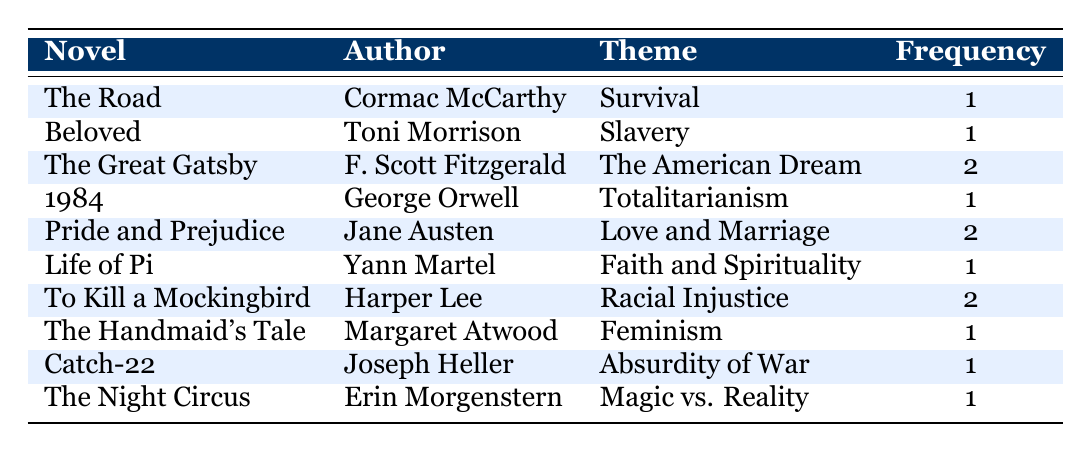What is the theme of "To Kill a Mockingbird"? "To Kill a Mockingbird" has the theme of "Racial Injustice," as directly stated in the table.
Answer: Racial Injustice How many novels have the theme of "Survival"? There is only one novel listed under the theme of "Survival," which is "The Road" by Cormac McCarthy.
Answer: 1 Which novel has the highest frequency of themes? The "Great Gatsby," "Pride and Prejudice," and "To Kill a Mockingbird" each have a frequency of 2, which is the highest among all listed.
Answer: The Great Gatsby, Pride and Prejudice, To Kill a Mockingbird Is "Feminism" listed as a theme in any award-winning novel? Yes, "Feminism" is listed as the theme for "The Handmaid's Tale" by Margaret Atwood.
Answer: Yes What is the total frequency of the themes "Love and Marriage" and "Racial Injustice"? The frequency for "Love and Marriage" is 2 (Pride and Prejudice) and for "Racial Injustice" is 2 (To Kill a Mockingbird). Adding these gives a total frequency of 2 + 2 = 4.
Answer: 4 How many authors have written novels with the theme of "Slavery"? Only one author, Toni Morrison, has written a novel with the theme of "Slavery," which is "Beloved."
Answer: 1 Which themes have a frequency of 1? The themes with a frequency of 1 are "Survival," "Slavery," "Totalitarianism," "Faith and Spirituality," "Feminism," "Absurdity of War," and "Magic vs. Reality." Seven themes in total.
Answer: 7 If you list the novels associated with the theme "The American Dream," how many are there? Only one novel, "The Great Gatsby" by F. Scott Fitzgerald, is associated with the theme "The American Dream," based on the table.
Answer: 1 Are there any novels that discuss themes related to faith? Yes, "Life of Pi" discusses the theme of "Faith and Spirituality."
Answer: Yes 